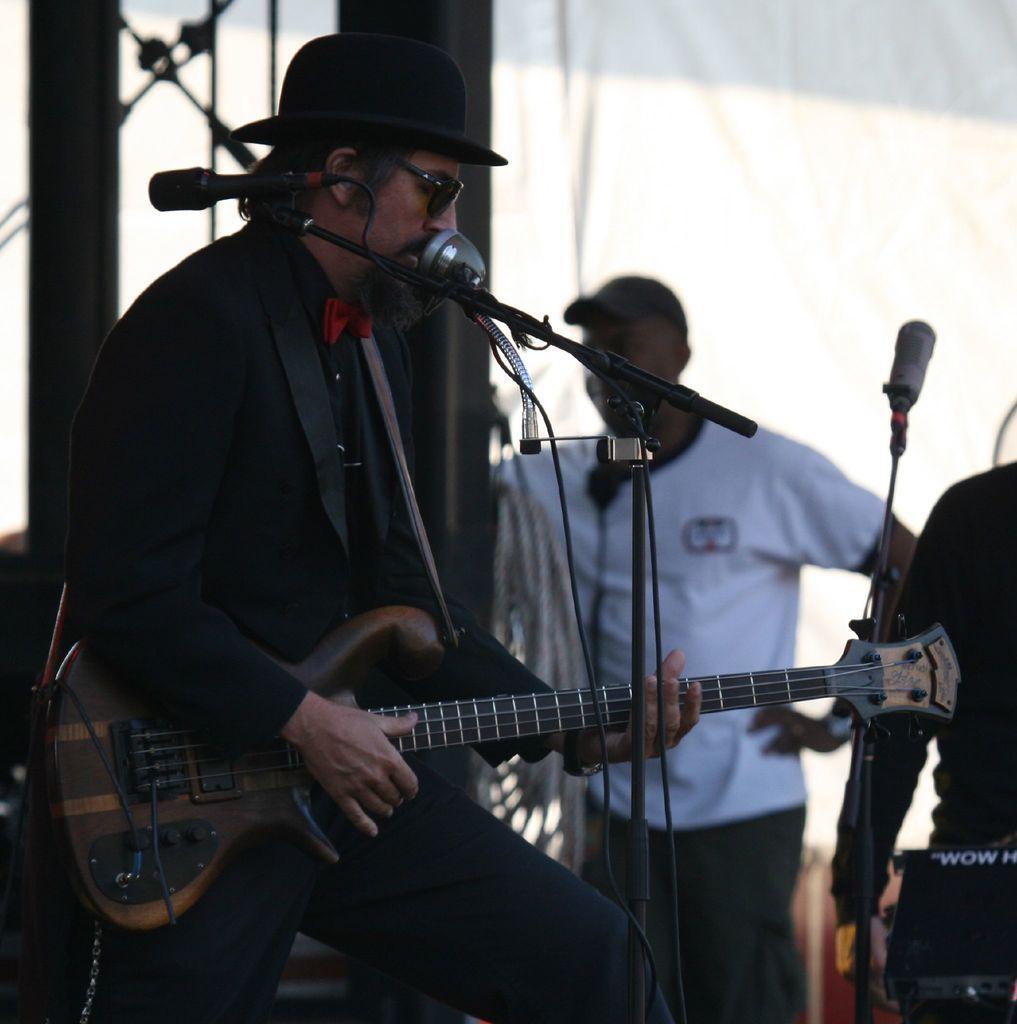Can you describe this image briefly? As we can see in the image there is a man holding guitar. In front of him there is a mic. 